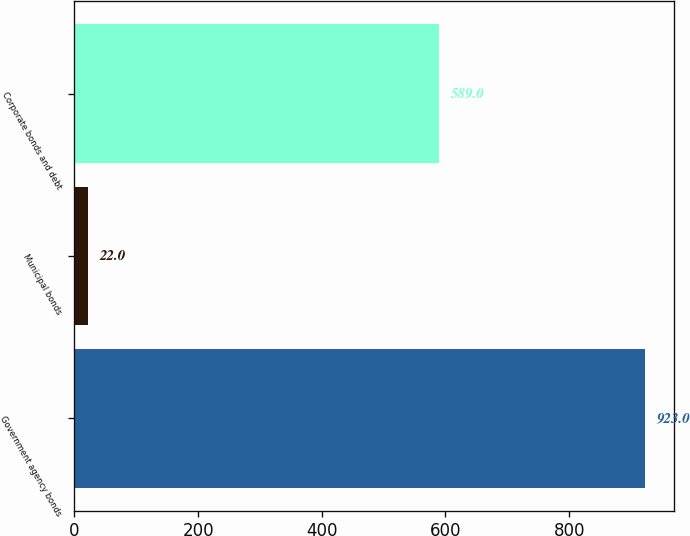<chart> <loc_0><loc_0><loc_500><loc_500><bar_chart><fcel>Government agency bonds<fcel>Municipal bonds<fcel>Corporate bonds and debt<nl><fcel>923<fcel>22<fcel>589<nl></chart> 